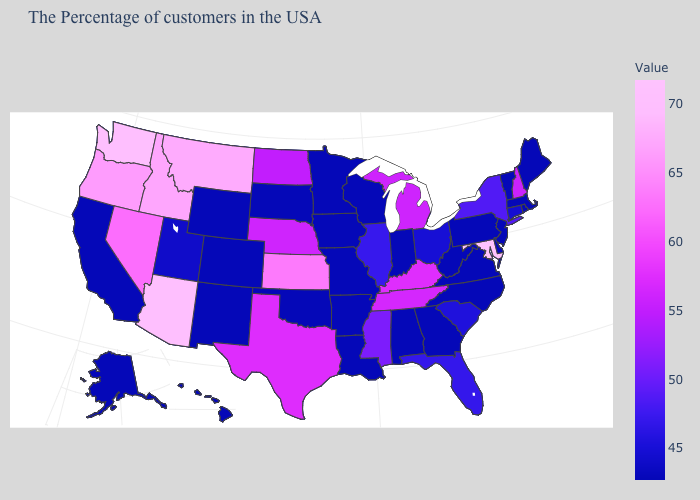Which states hav the highest value in the Northeast?
Give a very brief answer. New Hampshire. Among the states that border Oklahoma , which have the highest value?
Keep it brief. Kansas. Does South Carolina have a lower value than North Dakota?
Concise answer only. Yes. Which states have the highest value in the USA?
Write a very short answer. Maryland. 